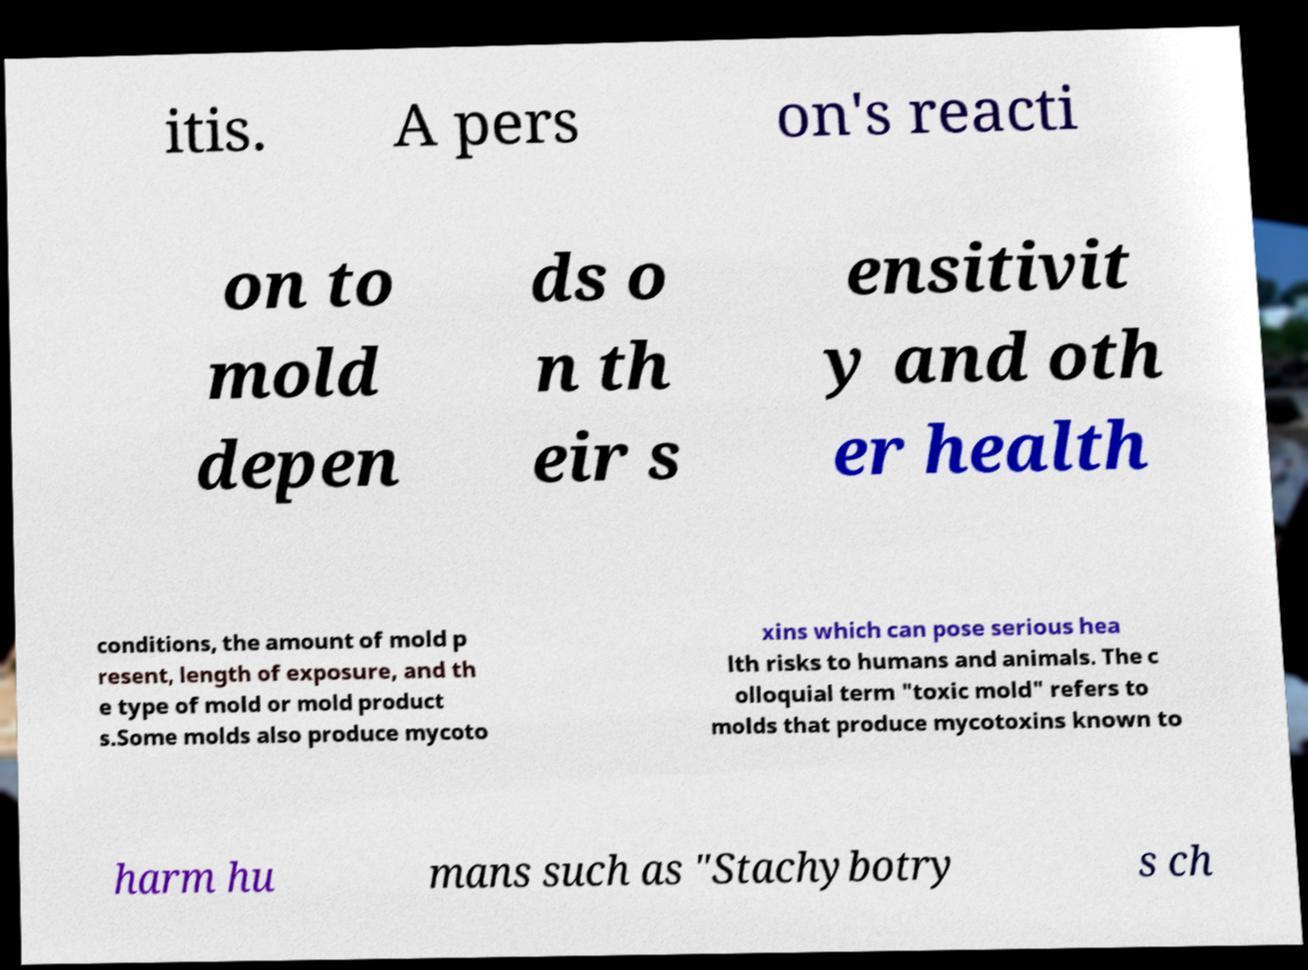I need the written content from this picture converted into text. Can you do that? itis. A pers on's reacti on to mold depen ds o n th eir s ensitivit y and oth er health conditions, the amount of mold p resent, length of exposure, and th e type of mold or mold product s.Some molds also produce mycoto xins which can pose serious hea lth risks to humans and animals. The c olloquial term "toxic mold" refers to molds that produce mycotoxins known to harm hu mans such as "Stachybotry s ch 